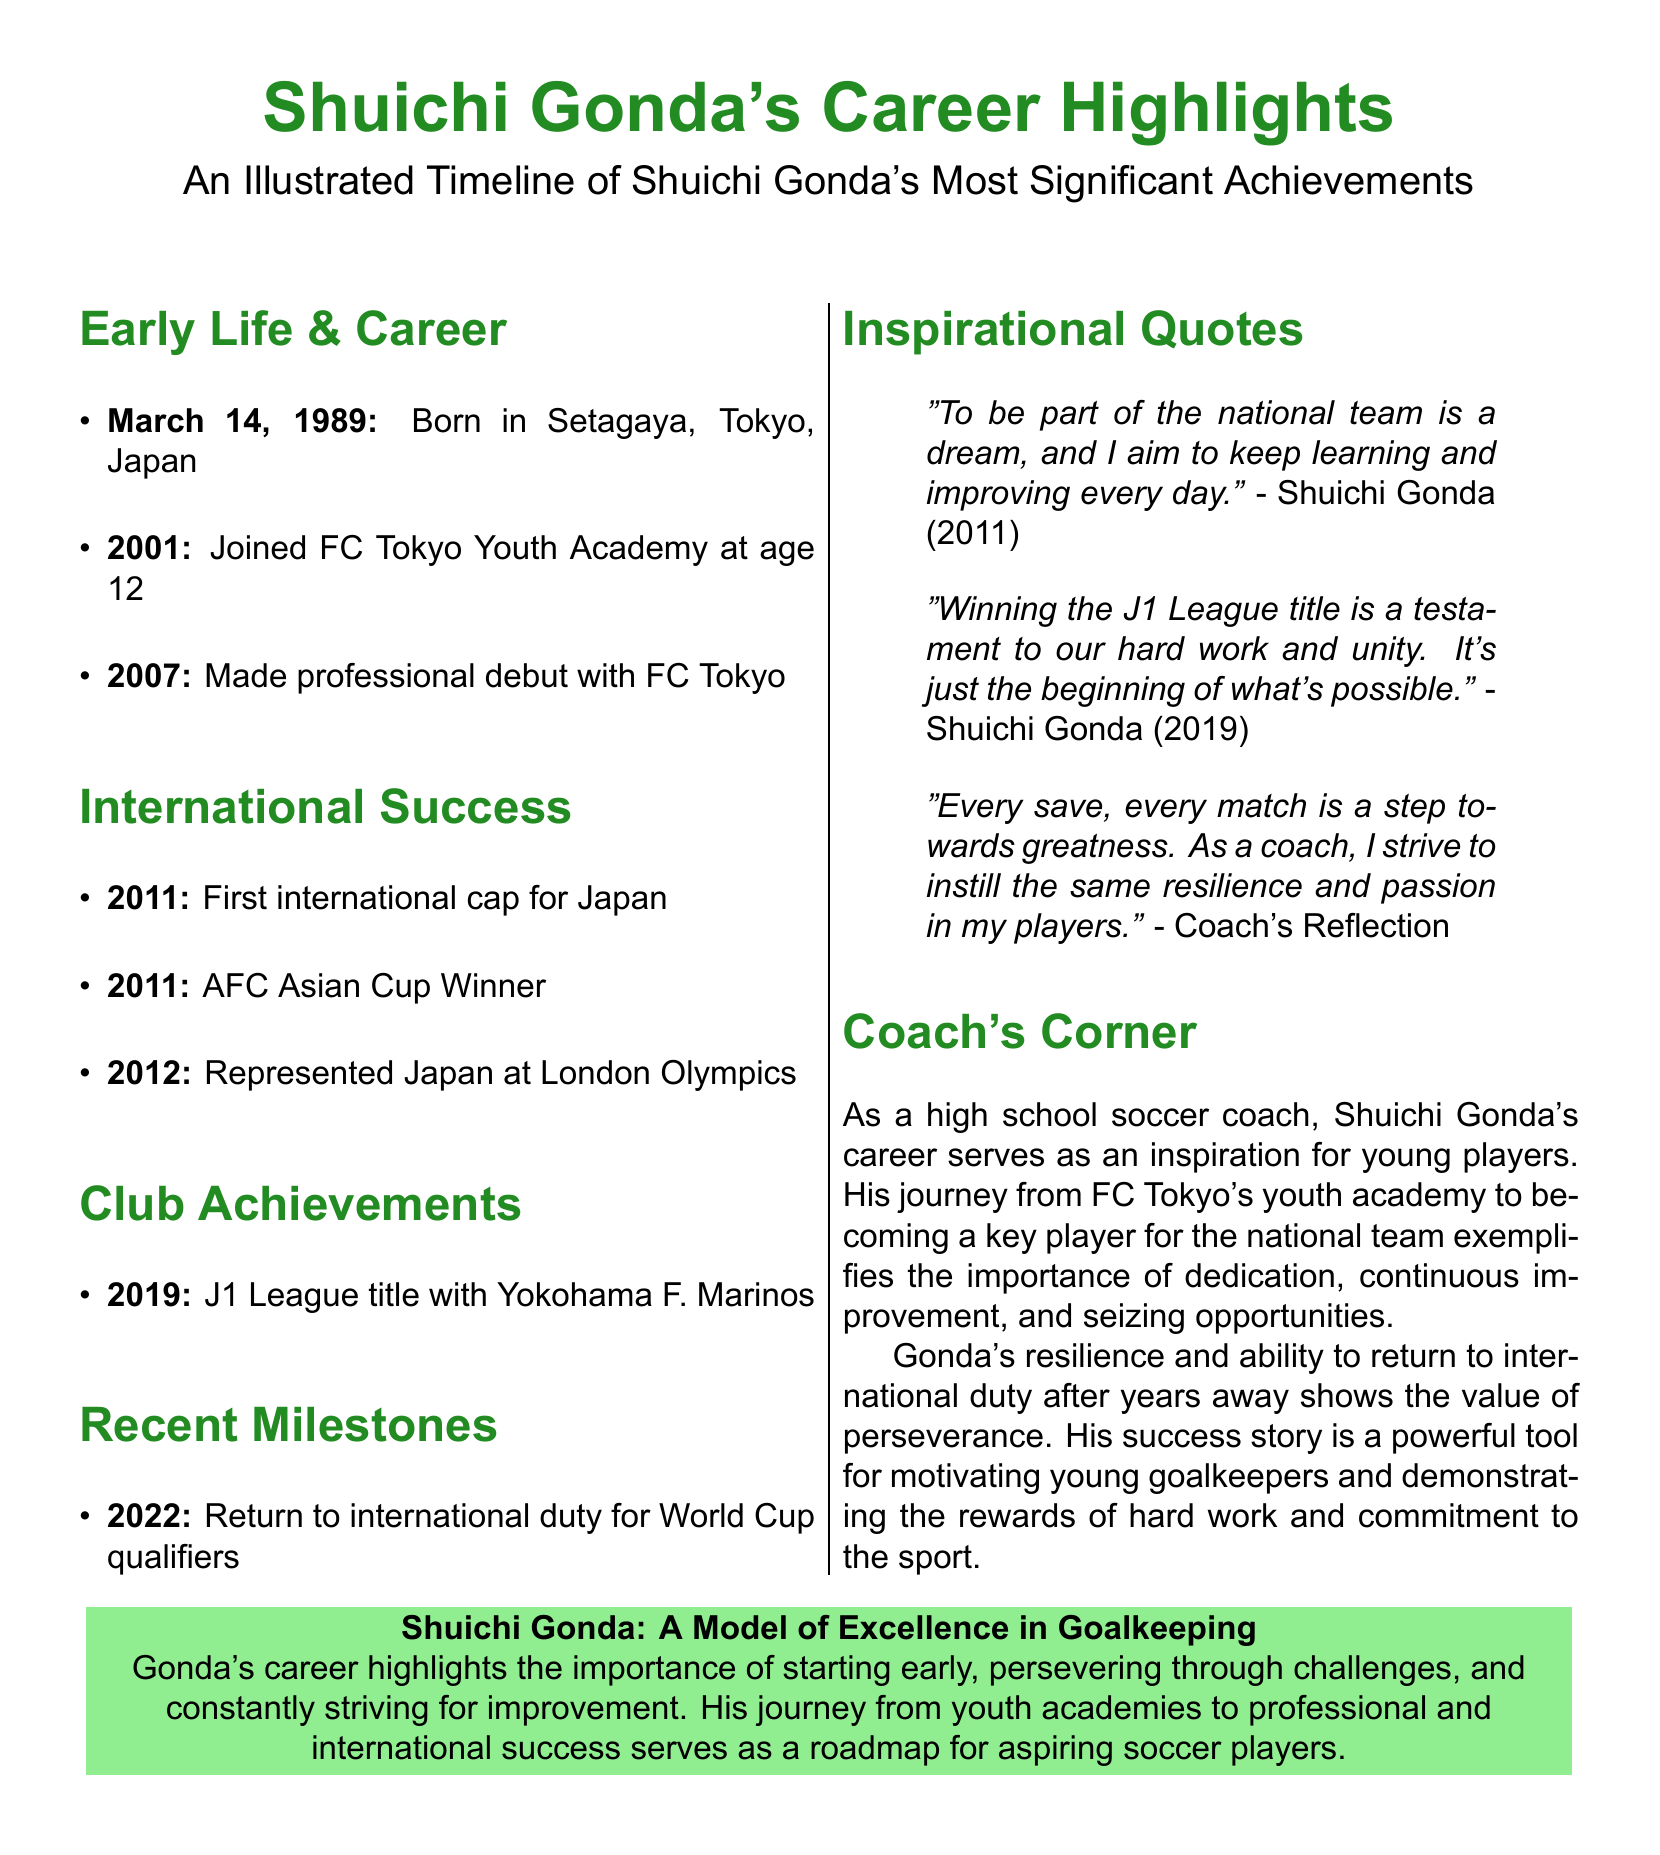What year was Shuichi Gonda born? The document states that Shuichi Gonda was born on March 14, 1989.
Answer: 1989 What club did Gonda join at age 12? According to the document, Gonda joined FC Tokyo Youth Academy at the age of 12.
Answer: FC Tokyo Youth Academy How many J1 League titles has Gonda won? The document mentions that Gonda won one J1 League title with Yokohama F. Marinos.
Answer: 1 In which year did Gonda make his professional debut? The document indicates that Gonda made his professional debut with FC Tokyo in 2007.
Answer: 2007 Which major tournament did Gonda win in 2011? The document specifies that Gonda won the AFC Asian Cup in 2011.
Answer: AFC Asian Cup What role did Shuichi Gonda play in his national team? The document lists Gonda's position as a goalkeeper for the national team.
Answer: Goalkeeper How has Gonda's career influenced young players according to "Coach's Corner"? The document explains that Gonda's career highlights dedication, continuous improvement, and seizing opportunities.
Answer: Dedication, continuous improvement, and seizing opportunities What was Gonda's inspirational quote about the national team? The document notes that Gonda mentioned, "To be part of the national team is a dream."
Answer: "To be part of the national team is a dream." In which year did Gonda return to international duty? The document states that Gonda returned to international duty in 2022 for World Cup qualifiers.
Answer: 2022 